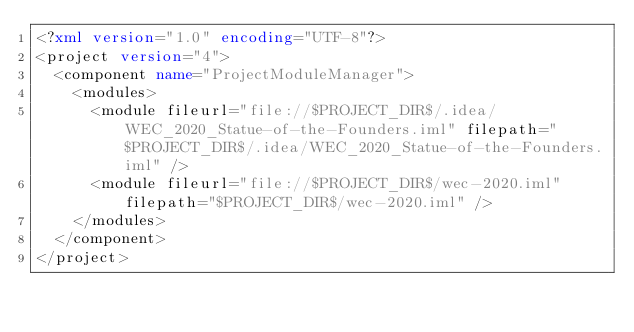<code> <loc_0><loc_0><loc_500><loc_500><_XML_><?xml version="1.0" encoding="UTF-8"?>
<project version="4">
  <component name="ProjectModuleManager">
    <modules>
      <module fileurl="file://$PROJECT_DIR$/.idea/WEC_2020_Statue-of-the-Founders.iml" filepath="$PROJECT_DIR$/.idea/WEC_2020_Statue-of-the-Founders.iml" />
      <module fileurl="file://$PROJECT_DIR$/wec-2020.iml" filepath="$PROJECT_DIR$/wec-2020.iml" />
    </modules>
  </component>
</project></code> 